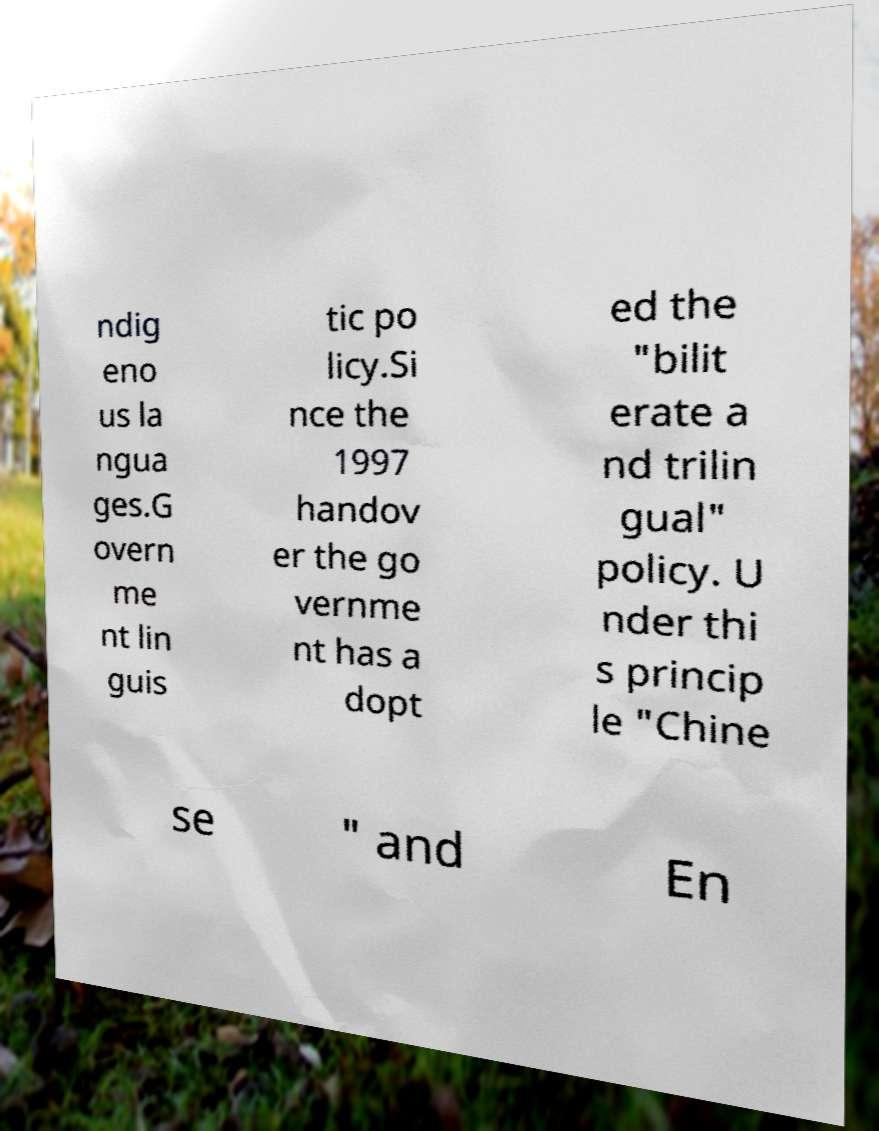Can you accurately transcribe the text from the provided image for me? ndig eno us la ngua ges.G overn me nt lin guis tic po licy.Si nce the 1997 handov er the go vernme nt has a dopt ed the "bilit erate a nd trilin gual" policy. U nder thi s princip le "Chine se " and En 